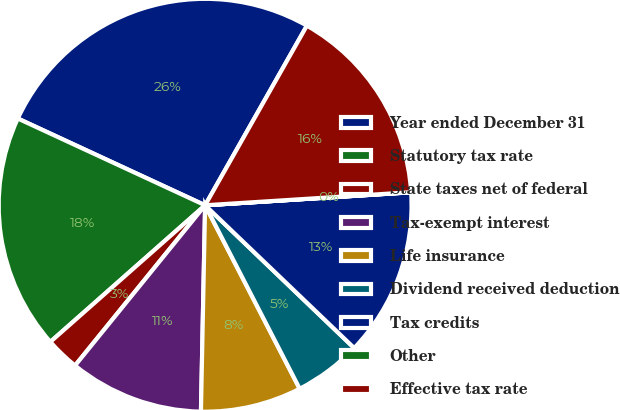Convert chart to OTSL. <chart><loc_0><loc_0><loc_500><loc_500><pie_chart><fcel>Year ended December 31<fcel>Statutory tax rate<fcel>State taxes net of federal<fcel>Tax-exempt interest<fcel>Life insurance<fcel>Dividend received deduction<fcel>Tax credits<fcel>Other<fcel>Effective tax rate<nl><fcel>26.31%<fcel>18.42%<fcel>2.64%<fcel>10.53%<fcel>7.9%<fcel>5.27%<fcel>13.16%<fcel>0.01%<fcel>15.79%<nl></chart> 